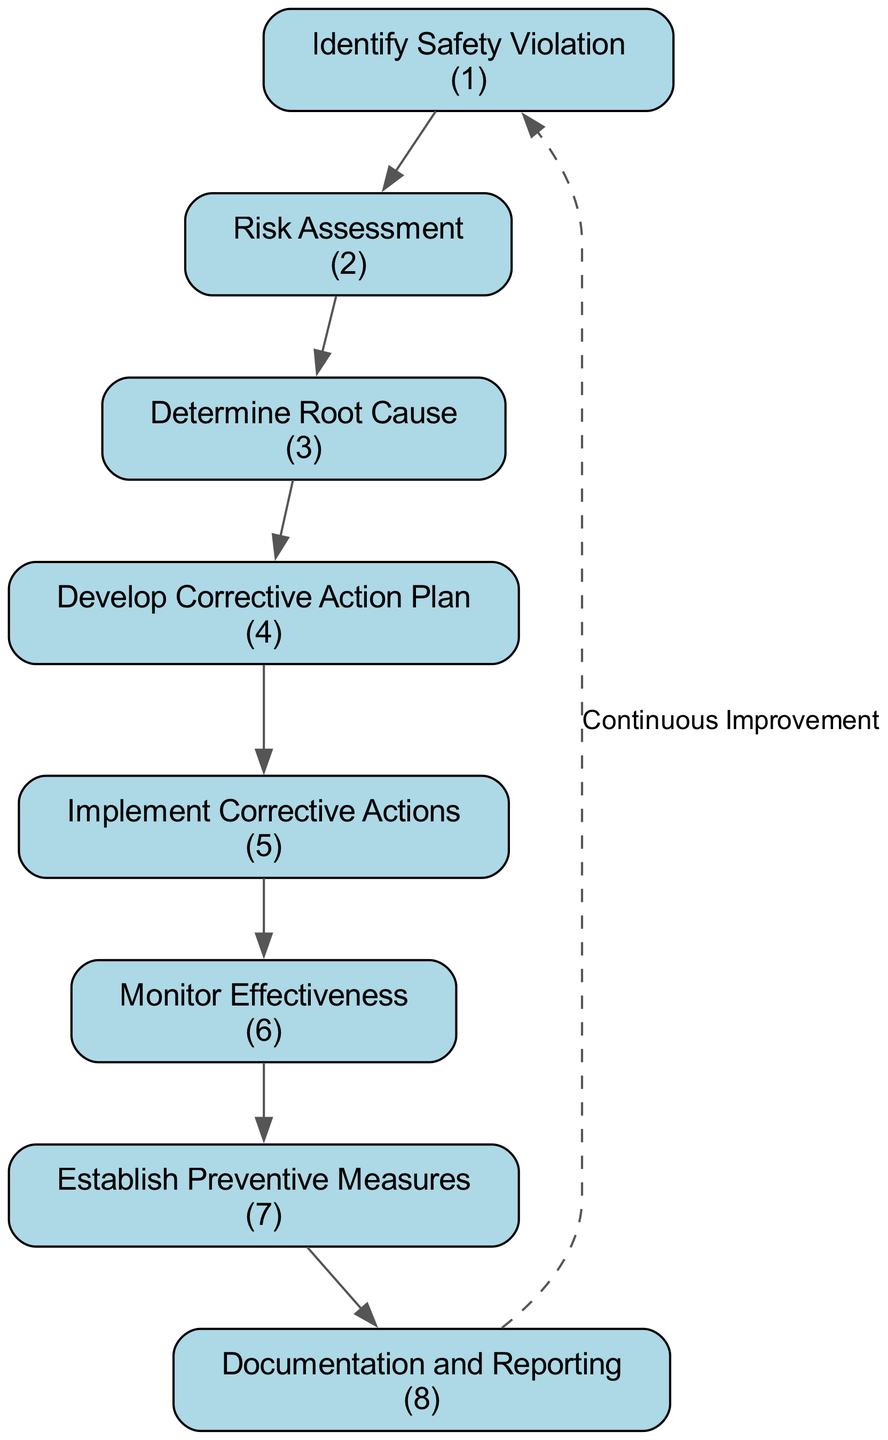What is the first step in the CAPA process? The diagram starts with the first node labeled "Identify Safety Violation," indicating that this is the first step in the process.
Answer: Identify Safety Violation How many total nodes are present in the diagram? There are eight nodes represented in the diagram, each representing a step in the Corrective and Preventive Action process.
Answer: Eight What is the last step in the CAPA process? The final node in the sequence, which represents the last step, is "Documentation and Reporting."
Answer: Documentation and Reporting What action follows "Determine Root Cause"? The next node after "Determine Root Cause" is "Develop Corrective Action Plan," indicating the subsequent step in the process.
Answer: Develop Corrective Action Plan Which step addresses the prevention of future violations? The node labeled "Establish Preventive Measures" specifically deals with creating strategies to prevent similar situations from recurring.
Answer: Establish Preventive Measures How do you evaluate if the corrective actions are effective? This is done in the "Monitor Effectiveness" step, which directly assesses whether the implemented corrective actions have resolved the safety violation.
Answer: Monitor Effectiveness What continuous aspect is indicated by the dashed line in the diagram? The dashed edge labeled "Continuous Improvement" reinforces the idea that the CAPA process is iterative, implying ongoing evaluation and enhancement beyond the documented steps.
Answer: Continuous Improvement Name the node responsible for action implementation. The node labeled "Implement Corrective Actions" specifies the execution of corrective measures, highlighting its role in the process.
Answer: Implement Corrective Actions 